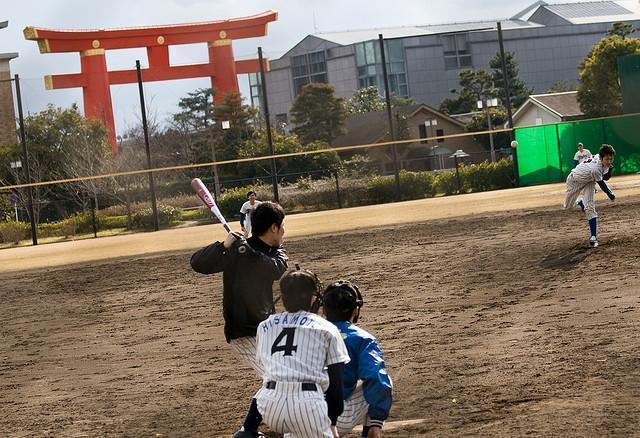How many people are there?
Give a very brief answer. 4. 